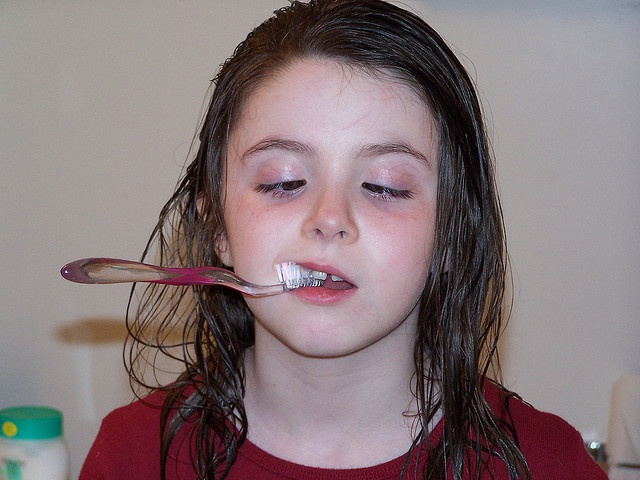Describe the objects in this image and their specific colors. I can see people in darkgray, black, maroon, and gray tones and toothbrush in darkgray, brown, maroon, and gray tones in this image. 